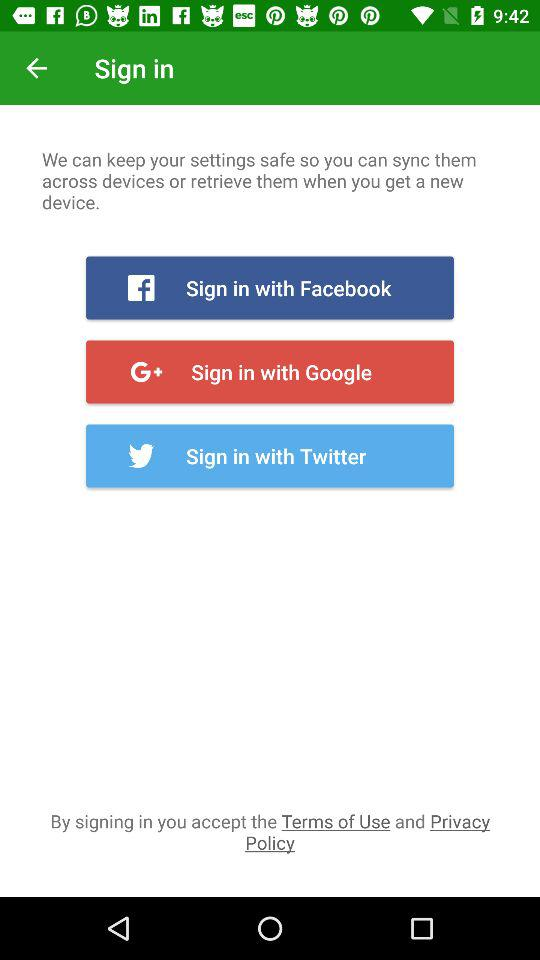How many sign in options are there?
Answer the question using a single word or phrase. 3 